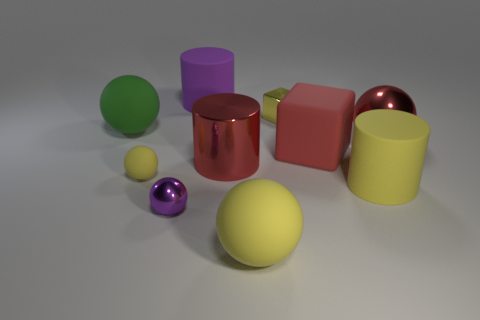Subtract all purple matte cylinders. How many cylinders are left? 2 Subtract all purple cylinders. How many yellow balls are left? 2 Subtract 1 cylinders. How many cylinders are left? 2 Subtract all yellow spheres. How many spheres are left? 3 Subtract all gray cylinders. Subtract all brown blocks. How many cylinders are left? 3 Subtract all cubes. How many objects are left? 8 Subtract 0 blue blocks. How many objects are left? 10 Subtract all big shiny cylinders. Subtract all purple rubber objects. How many objects are left? 8 Add 5 large red shiny things. How many large red shiny things are left? 7 Add 7 red objects. How many red objects exist? 10 